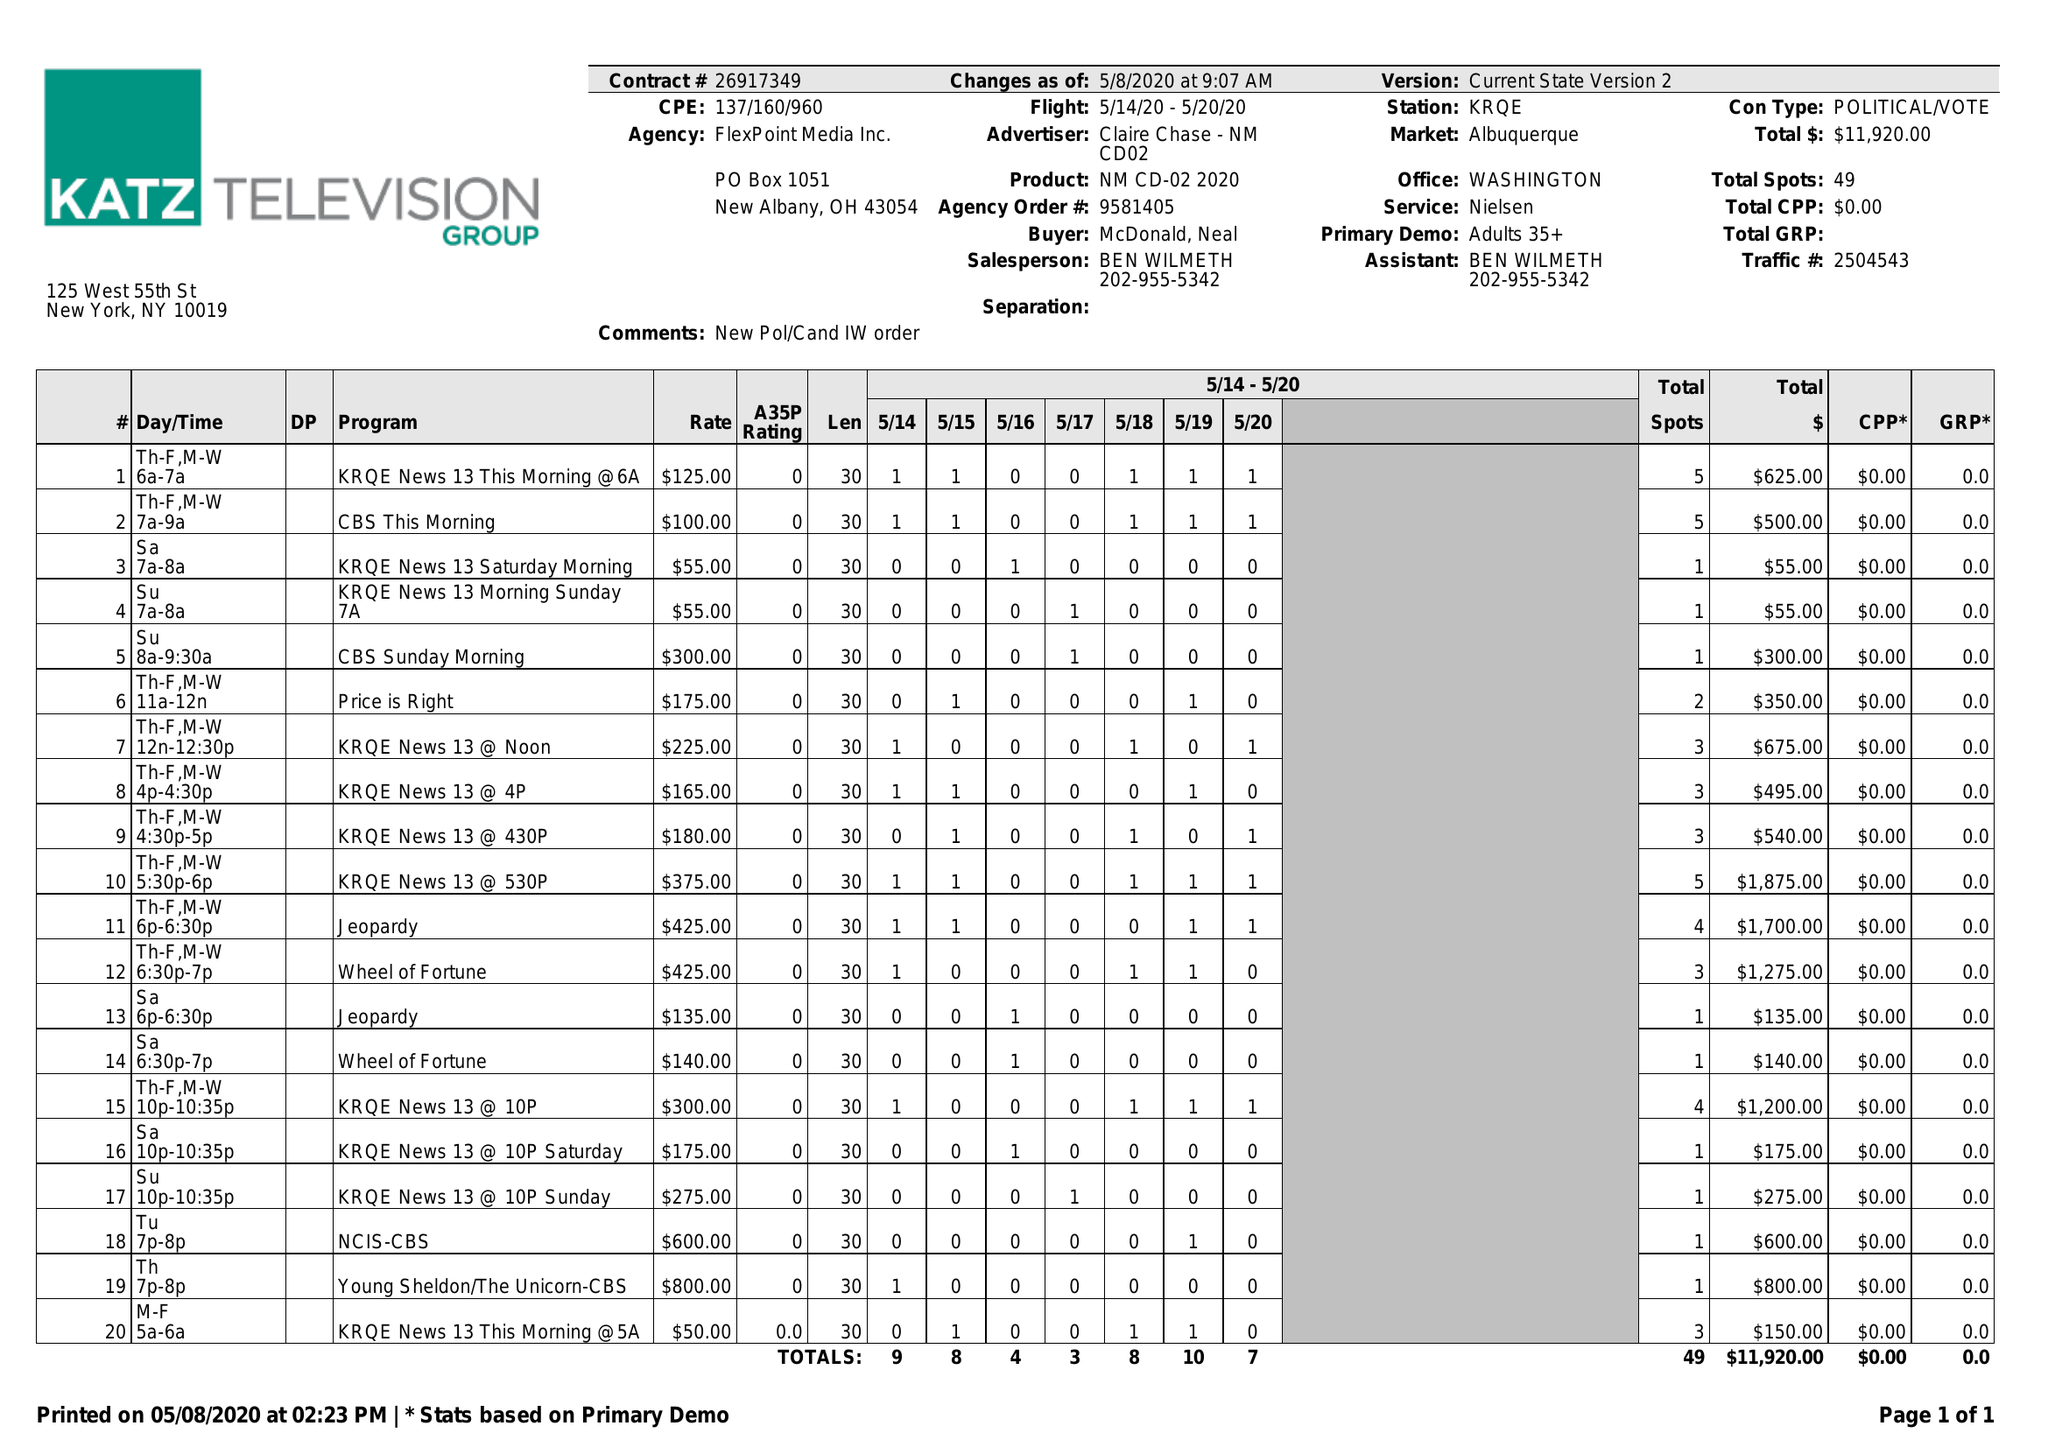What is the value for the flight_from?
Answer the question using a single word or phrase. 05/14/20 